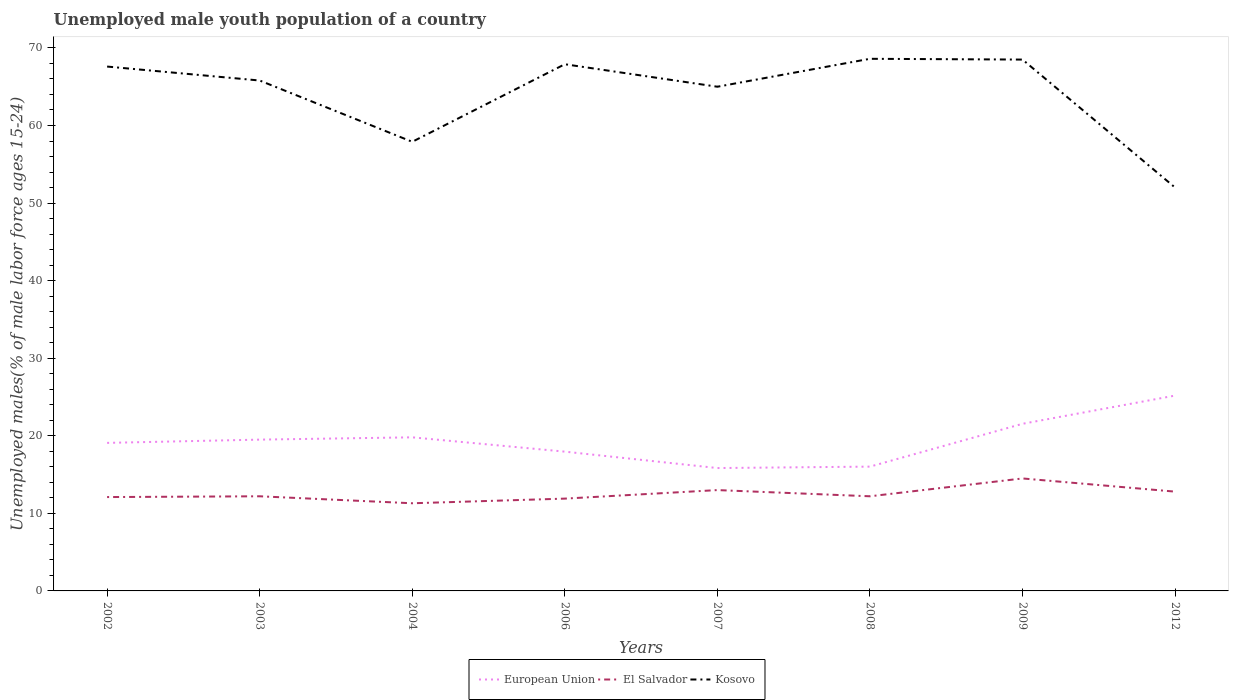How many different coloured lines are there?
Give a very brief answer. 3. Is the number of lines equal to the number of legend labels?
Provide a succinct answer. Yes. What is the total percentage of unemployed male youth population in Kosovo in the graph?
Your response must be concise. 0.1. What is the difference between the highest and the second highest percentage of unemployed male youth population in El Salvador?
Make the answer very short. 3.2. What is the difference between the highest and the lowest percentage of unemployed male youth population in El Salvador?
Your answer should be very brief. 3. How many lines are there?
Provide a succinct answer. 3. How many years are there in the graph?
Ensure brevity in your answer.  8. How are the legend labels stacked?
Your answer should be very brief. Horizontal. What is the title of the graph?
Offer a very short reply. Unemployed male youth population of a country. What is the label or title of the Y-axis?
Offer a terse response. Unemployed males(% of male labor force ages 15-24). What is the Unemployed males(% of male labor force ages 15-24) of European Union in 2002?
Ensure brevity in your answer.  19.08. What is the Unemployed males(% of male labor force ages 15-24) in El Salvador in 2002?
Make the answer very short. 12.1. What is the Unemployed males(% of male labor force ages 15-24) in Kosovo in 2002?
Provide a short and direct response. 67.6. What is the Unemployed males(% of male labor force ages 15-24) of European Union in 2003?
Offer a very short reply. 19.51. What is the Unemployed males(% of male labor force ages 15-24) of El Salvador in 2003?
Give a very brief answer. 12.2. What is the Unemployed males(% of male labor force ages 15-24) in Kosovo in 2003?
Offer a terse response. 65.8. What is the Unemployed males(% of male labor force ages 15-24) of European Union in 2004?
Make the answer very short. 19.8. What is the Unemployed males(% of male labor force ages 15-24) in El Salvador in 2004?
Offer a very short reply. 11.3. What is the Unemployed males(% of male labor force ages 15-24) of Kosovo in 2004?
Provide a succinct answer. 57.9. What is the Unemployed males(% of male labor force ages 15-24) of European Union in 2006?
Your answer should be compact. 17.96. What is the Unemployed males(% of male labor force ages 15-24) in El Salvador in 2006?
Offer a very short reply. 11.9. What is the Unemployed males(% of male labor force ages 15-24) of Kosovo in 2006?
Provide a short and direct response. 67.9. What is the Unemployed males(% of male labor force ages 15-24) in European Union in 2007?
Offer a terse response. 15.84. What is the Unemployed males(% of male labor force ages 15-24) in El Salvador in 2007?
Your answer should be compact. 13. What is the Unemployed males(% of male labor force ages 15-24) in Kosovo in 2007?
Offer a very short reply. 65. What is the Unemployed males(% of male labor force ages 15-24) in European Union in 2008?
Make the answer very short. 16.02. What is the Unemployed males(% of male labor force ages 15-24) of El Salvador in 2008?
Provide a succinct answer. 12.2. What is the Unemployed males(% of male labor force ages 15-24) of Kosovo in 2008?
Your answer should be compact. 68.6. What is the Unemployed males(% of male labor force ages 15-24) in European Union in 2009?
Provide a succinct answer. 21.55. What is the Unemployed males(% of male labor force ages 15-24) of El Salvador in 2009?
Provide a succinct answer. 14.5. What is the Unemployed males(% of male labor force ages 15-24) in Kosovo in 2009?
Give a very brief answer. 68.5. What is the Unemployed males(% of male labor force ages 15-24) of European Union in 2012?
Give a very brief answer. 25.18. What is the Unemployed males(% of male labor force ages 15-24) in El Salvador in 2012?
Provide a short and direct response. 12.8. What is the Unemployed males(% of male labor force ages 15-24) in Kosovo in 2012?
Your answer should be very brief. 52. Across all years, what is the maximum Unemployed males(% of male labor force ages 15-24) of European Union?
Provide a short and direct response. 25.18. Across all years, what is the maximum Unemployed males(% of male labor force ages 15-24) of Kosovo?
Ensure brevity in your answer.  68.6. Across all years, what is the minimum Unemployed males(% of male labor force ages 15-24) of European Union?
Your response must be concise. 15.84. Across all years, what is the minimum Unemployed males(% of male labor force ages 15-24) of El Salvador?
Give a very brief answer. 11.3. Across all years, what is the minimum Unemployed males(% of male labor force ages 15-24) in Kosovo?
Give a very brief answer. 52. What is the total Unemployed males(% of male labor force ages 15-24) of European Union in the graph?
Your response must be concise. 154.94. What is the total Unemployed males(% of male labor force ages 15-24) of Kosovo in the graph?
Your response must be concise. 513.3. What is the difference between the Unemployed males(% of male labor force ages 15-24) in European Union in 2002 and that in 2003?
Offer a terse response. -0.42. What is the difference between the Unemployed males(% of male labor force ages 15-24) of El Salvador in 2002 and that in 2003?
Ensure brevity in your answer.  -0.1. What is the difference between the Unemployed males(% of male labor force ages 15-24) in European Union in 2002 and that in 2004?
Your answer should be very brief. -0.72. What is the difference between the Unemployed males(% of male labor force ages 15-24) in El Salvador in 2002 and that in 2004?
Ensure brevity in your answer.  0.8. What is the difference between the Unemployed males(% of male labor force ages 15-24) of Kosovo in 2002 and that in 2004?
Provide a short and direct response. 9.7. What is the difference between the Unemployed males(% of male labor force ages 15-24) in European Union in 2002 and that in 2006?
Keep it short and to the point. 1.13. What is the difference between the Unemployed males(% of male labor force ages 15-24) of El Salvador in 2002 and that in 2006?
Provide a short and direct response. 0.2. What is the difference between the Unemployed males(% of male labor force ages 15-24) of Kosovo in 2002 and that in 2006?
Offer a very short reply. -0.3. What is the difference between the Unemployed males(% of male labor force ages 15-24) in European Union in 2002 and that in 2007?
Your answer should be compact. 3.24. What is the difference between the Unemployed males(% of male labor force ages 15-24) in Kosovo in 2002 and that in 2007?
Keep it short and to the point. 2.6. What is the difference between the Unemployed males(% of male labor force ages 15-24) of European Union in 2002 and that in 2008?
Your answer should be very brief. 3.06. What is the difference between the Unemployed males(% of male labor force ages 15-24) of El Salvador in 2002 and that in 2008?
Offer a terse response. -0.1. What is the difference between the Unemployed males(% of male labor force ages 15-24) in European Union in 2002 and that in 2009?
Your answer should be very brief. -2.46. What is the difference between the Unemployed males(% of male labor force ages 15-24) of Kosovo in 2002 and that in 2009?
Make the answer very short. -0.9. What is the difference between the Unemployed males(% of male labor force ages 15-24) of European Union in 2002 and that in 2012?
Keep it short and to the point. -6.1. What is the difference between the Unemployed males(% of male labor force ages 15-24) of El Salvador in 2002 and that in 2012?
Ensure brevity in your answer.  -0.7. What is the difference between the Unemployed males(% of male labor force ages 15-24) of European Union in 2003 and that in 2004?
Offer a terse response. -0.3. What is the difference between the Unemployed males(% of male labor force ages 15-24) of European Union in 2003 and that in 2006?
Your response must be concise. 1.55. What is the difference between the Unemployed males(% of male labor force ages 15-24) in El Salvador in 2003 and that in 2006?
Your answer should be compact. 0.3. What is the difference between the Unemployed males(% of male labor force ages 15-24) of Kosovo in 2003 and that in 2006?
Ensure brevity in your answer.  -2.1. What is the difference between the Unemployed males(% of male labor force ages 15-24) in European Union in 2003 and that in 2007?
Your answer should be compact. 3.66. What is the difference between the Unemployed males(% of male labor force ages 15-24) in El Salvador in 2003 and that in 2007?
Your answer should be compact. -0.8. What is the difference between the Unemployed males(% of male labor force ages 15-24) of European Union in 2003 and that in 2008?
Offer a terse response. 3.48. What is the difference between the Unemployed males(% of male labor force ages 15-24) of European Union in 2003 and that in 2009?
Provide a short and direct response. -2.04. What is the difference between the Unemployed males(% of male labor force ages 15-24) in El Salvador in 2003 and that in 2009?
Keep it short and to the point. -2.3. What is the difference between the Unemployed males(% of male labor force ages 15-24) of European Union in 2003 and that in 2012?
Provide a short and direct response. -5.68. What is the difference between the Unemployed males(% of male labor force ages 15-24) in El Salvador in 2003 and that in 2012?
Give a very brief answer. -0.6. What is the difference between the Unemployed males(% of male labor force ages 15-24) of European Union in 2004 and that in 2006?
Offer a very short reply. 1.85. What is the difference between the Unemployed males(% of male labor force ages 15-24) of Kosovo in 2004 and that in 2006?
Offer a terse response. -10. What is the difference between the Unemployed males(% of male labor force ages 15-24) in European Union in 2004 and that in 2007?
Provide a short and direct response. 3.96. What is the difference between the Unemployed males(% of male labor force ages 15-24) of European Union in 2004 and that in 2008?
Ensure brevity in your answer.  3.78. What is the difference between the Unemployed males(% of male labor force ages 15-24) in Kosovo in 2004 and that in 2008?
Your answer should be compact. -10.7. What is the difference between the Unemployed males(% of male labor force ages 15-24) of European Union in 2004 and that in 2009?
Make the answer very short. -1.74. What is the difference between the Unemployed males(% of male labor force ages 15-24) of Kosovo in 2004 and that in 2009?
Make the answer very short. -10.6. What is the difference between the Unemployed males(% of male labor force ages 15-24) in European Union in 2004 and that in 2012?
Keep it short and to the point. -5.38. What is the difference between the Unemployed males(% of male labor force ages 15-24) of Kosovo in 2004 and that in 2012?
Your answer should be compact. 5.9. What is the difference between the Unemployed males(% of male labor force ages 15-24) in European Union in 2006 and that in 2007?
Ensure brevity in your answer.  2.12. What is the difference between the Unemployed males(% of male labor force ages 15-24) of El Salvador in 2006 and that in 2007?
Make the answer very short. -1.1. What is the difference between the Unemployed males(% of male labor force ages 15-24) of Kosovo in 2006 and that in 2007?
Make the answer very short. 2.9. What is the difference between the Unemployed males(% of male labor force ages 15-24) in European Union in 2006 and that in 2008?
Keep it short and to the point. 1.93. What is the difference between the Unemployed males(% of male labor force ages 15-24) in European Union in 2006 and that in 2009?
Your answer should be compact. -3.59. What is the difference between the Unemployed males(% of male labor force ages 15-24) of European Union in 2006 and that in 2012?
Your response must be concise. -7.23. What is the difference between the Unemployed males(% of male labor force ages 15-24) in Kosovo in 2006 and that in 2012?
Offer a very short reply. 15.9. What is the difference between the Unemployed males(% of male labor force ages 15-24) in European Union in 2007 and that in 2008?
Your answer should be compact. -0.18. What is the difference between the Unemployed males(% of male labor force ages 15-24) of El Salvador in 2007 and that in 2008?
Your response must be concise. 0.8. What is the difference between the Unemployed males(% of male labor force ages 15-24) in European Union in 2007 and that in 2009?
Provide a short and direct response. -5.7. What is the difference between the Unemployed males(% of male labor force ages 15-24) in El Salvador in 2007 and that in 2009?
Offer a very short reply. -1.5. What is the difference between the Unemployed males(% of male labor force ages 15-24) of Kosovo in 2007 and that in 2009?
Provide a short and direct response. -3.5. What is the difference between the Unemployed males(% of male labor force ages 15-24) in European Union in 2007 and that in 2012?
Ensure brevity in your answer.  -9.34. What is the difference between the Unemployed males(% of male labor force ages 15-24) in El Salvador in 2007 and that in 2012?
Make the answer very short. 0.2. What is the difference between the Unemployed males(% of male labor force ages 15-24) of Kosovo in 2007 and that in 2012?
Your answer should be very brief. 13. What is the difference between the Unemployed males(% of male labor force ages 15-24) of European Union in 2008 and that in 2009?
Your answer should be very brief. -5.52. What is the difference between the Unemployed males(% of male labor force ages 15-24) of Kosovo in 2008 and that in 2009?
Your answer should be compact. 0.1. What is the difference between the Unemployed males(% of male labor force ages 15-24) of European Union in 2008 and that in 2012?
Offer a terse response. -9.16. What is the difference between the Unemployed males(% of male labor force ages 15-24) of European Union in 2009 and that in 2012?
Your response must be concise. -3.64. What is the difference between the Unemployed males(% of male labor force ages 15-24) in Kosovo in 2009 and that in 2012?
Provide a succinct answer. 16.5. What is the difference between the Unemployed males(% of male labor force ages 15-24) in European Union in 2002 and the Unemployed males(% of male labor force ages 15-24) in El Salvador in 2003?
Provide a short and direct response. 6.88. What is the difference between the Unemployed males(% of male labor force ages 15-24) in European Union in 2002 and the Unemployed males(% of male labor force ages 15-24) in Kosovo in 2003?
Your answer should be very brief. -46.72. What is the difference between the Unemployed males(% of male labor force ages 15-24) of El Salvador in 2002 and the Unemployed males(% of male labor force ages 15-24) of Kosovo in 2003?
Keep it short and to the point. -53.7. What is the difference between the Unemployed males(% of male labor force ages 15-24) in European Union in 2002 and the Unemployed males(% of male labor force ages 15-24) in El Salvador in 2004?
Your response must be concise. 7.78. What is the difference between the Unemployed males(% of male labor force ages 15-24) of European Union in 2002 and the Unemployed males(% of male labor force ages 15-24) of Kosovo in 2004?
Your answer should be very brief. -38.82. What is the difference between the Unemployed males(% of male labor force ages 15-24) in El Salvador in 2002 and the Unemployed males(% of male labor force ages 15-24) in Kosovo in 2004?
Your answer should be compact. -45.8. What is the difference between the Unemployed males(% of male labor force ages 15-24) of European Union in 2002 and the Unemployed males(% of male labor force ages 15-24) of El Salvador in 2006?
Offer a terse response. 7.18. What is the difference between the Unemployed males(% of male labor force ages 15-24) of European Union in 2002 and the Unemployed males(% of male labor force ages 15-24) of Kosovo in 2006?
Provide a short and direct response. -48.82. What is the difference between the Unemployed males(% of male labor force ages 15-24) of El Salvador in 2002 and the Unemployed males(% of male labor force ages 15-24) of Kosovo in 2006?
Your answer should be very brief. -55.8. What is the difference between the Unemployed males(% of male labor force ages 15-24) of European Union in 2002 and the Unemployed males(% of male labor force ages 15-24) of El Salvador in 2007?
Ensure brevity in your answer.  6.08. What is the difference between the Unemployed males(% of male labor force ages 15-24) of European Union in 2002 and the Unemployed males(% of male labor force ages 15-24) of Kosovo in 2007?
Offer a terse response. -45.92. What is the difference between the Unemployed males(% of male labor force ages 15-24) in El Salvador in 2002 and the Unemployed males(% of male labor force ages 15-24) in Kosovo in 2007?
Offer a very short reply. -52.9. What is the difference between the Unemployed males(% of male labor force ages 15-24) of European Union in 2002 and the Unemployed males(% of male labor force ages 15-24) of El Salvador in 2008?
Your answer should be compact. 6.88. What is the difference between the Unemployed males(% of male labor force ages 15-24) of European Union in 2002 and the Unemployed males(% of male labor force ages 15-24) of Kosovo in 2008?
Provide a short and direct response. -49.52. What is the difference between the Unemployed males(% of male labor force ages 15-24) in El Salvador in 2002 and the Unemployed males(% of male labor force ages 15-24) in Kosovo in 2008?
Offer a very short reply. -56.5. What is the difference between the Unemployed males(% of male labor force ages 15-24) of European Union in 2002 and the Unemployed males(% of male labor force ages 15-24) of El Salvador in 2009?
Make the answer very short. 4.58. What is the difference between the Unemployed males(% of male labor force ages 15-24) in European Union in 2002 and the Unemployed males(% of male labor force ages 15-24) in Kosovo in 2009?
Provide a succinct answer. -49.42. What is the difference between the Unemployed males(% of male labor force ages 15-24) in El Salvador in 2002 and the Unemployed males(% of male labor force ages 15-24) in Kosovo in 2009?
Give a very brief answer. -56.4. What is the difference between the Unemployed males(% of male labor force ages 15-24) of European Union in 2002 and the Unemployed males(% of male labor force ages 15-24) of El Salvador in 2012?
Offer a terse response. 6.28. What is the difference between the Unemployed males(% of male labor force ages 15-24) in European Union in 2002 and the Unemployed males(% of male labor force ages 15-24) in Kosovo in 2012?
Provide a succinct answer. -32.92. What is the difference between the Unemployed males(% of male labor force ages 15-24) in El Salvador in 2002 and the Unemployed males(% of male labor force ages 15-24) in Kosovo in 2012?
Your answer should be compact. -39.9. What is the difference between the Unemployed males(% of male labor force ages 15-24) of European Union in 2003 and the Unemployed males(% of male labor force ages 15-24) of El Salvador in 2004?
Give a very brief answer. 8.21. What is the difference between the Unemployed males(% of male labor force ages 15-24) in European Union in 2003 and the Unemployed males(% of male labor force ages 15-24) in Kosovo in 2004?
Your answer should be very brief. -38.39. What is the difference between the Unemployed males(% of male labor force ages 15-24) of El Salvador in 2003 and the Unemployed males(% of male labor force ages 15-24) of Kosovo in 2004?
Your response must be concise. -45.7. What is the difference between the Unemployed males(% of male labor force ages 15-24) in European Union in 2003 and the Unemployed males(% of male labor force ages 15-24) in El Salvador in 2006?
Give a very brief answer. 7.61. What is the difference between the Unemployed males(% of male labor force ages 15-24) of European Union in 2003 and the Unemployed males(% of male labor force ages 15-24) of Kosovo in 2006?
Your response must be concise. -48.39. What is the difference between the Unemployed males(% of male labor force ages 15-24) in El Salvador in 2003 and the Unemployed males(% of male labor force ages 15-24) in Kosovo in 2006?
Ensure brevity in your answer.  -55.7. What is the difference between the Unemployed males(% of male labor force ages 15-24) in European Union in 2003 and the Unemployed males(% of male labor force ages 15-24) in El Salvador in 2007?
Offer a very short reply. 6.51. What is the difference between the Unemployed males(% of male labor force ages 15-24) of European Union in 2003 and the Unemployed males(% of male labor force ages 15-24) of Kosovo in 2007?
Your response must be concise. -45.49. What is the difference between the Unemployed males(% of male labor force ages 15-24) in El Salvador in 2003 and the Unemployed males(% of male labor force ages 15-24) in Kosovo in 2007?
Your answer should be very brief. -52.8. What is the difference between the Unemployed males(% of male labor force ages 15-24) of European Union in 2003 and the Unemployed males(% of male labor force ages 15-24) of El Salvador in 2008?
Give a very brief answer. 7.31. What is the difference between the Unemployed males(% of male labor force ages 15-24) in European Union in 2003 and the Unemployed males(% of male labor force ages 15-24) in Kosovo in 2008?
Provide a short and direct response. -49.09. What is the difference between the Unemployed males(% of male labor force ages 15-24) in El Salvador in 2003 and the Unemployed males(% of male labor force ages 15-24) in Kosovo in 2008?
Offer a terse response. -56.4. What is the difference between the Unemployed males(% of male labor force ages 15-24) of European Union in 2003 and the Unemployed males(% of male labor force ages 15-24) of El Salvador in 2009?
Your response must be concise. 5.01. What is the difference between the Unemployed males(% of male labor force ages 15-24) of European Union in 2003 and the Unemployed males(% of male labor force ages 15-24) of Kosovo in 2009?
Your answer should be very brief. -48.99. What is the difference between the Unemployed males(% of male labor force ages 15-24) of El Salvador in 2003 and the Unemployed males(% of male labor force ages 15-24) of Kosovo in 2009?
Provide a succinct answer. -56.3. What is the difference between the Unemployed males(% of male labor force ages 15-24) in European Union in 2003 and the Unemployed males(% of male labor force ages 15-24) in El Salvador in 2012?
Keep it short and to the point. 6.71. What is the difference between the Unemployed males(% of male labor force ages 15-24) in European Union in 2003 and the Unemployed males(% of male labor force ages 15-24) in Kosovo in 2012?
Offer a terse response. -32.49. What is the difference between the Unemployed males(% of male labor force ages 15-24) in El Salvador in 2003 and the Unemployed males(% of male labor force ages 15-24) in Kosovo in 2012?
Offer a very short reply. -39.8. What is the difference between the Unemployed males(% of male labor force ages 15-24) of European Union in 2004 and the Unemployed males(% of male labor force ages 15-24) of El Salvador in 2006?
Your answer should be very brief. 7.9. What is the difference between the Unemployed males(% of male labor force ages 15-24) in European Union in 2004 and the Unemployed males(% of male labor force ages 15-24) in Kosovo in 2006?
Offer a terse response. -48.1. What is the difference between the Unemployed males(% of male labor force ages 15-24) of El Salvador in 2004 and the Unemployed males(% of male labor force ages 15-24) of Kosovo in 2006?
Provide a succinct answer. -56.6. What is the difference between the Unemployed males(% of male labor force ages 15-24) in European Union in 2004 and the Unemployed males(% of male labor force ages 15-24) in El Salvador in 2007?
Give a very brief answer. 6.8. What is the difference between the Unemployed males(% of male labor force ages 15-24) in European Union in 2004 and the Unemployed males(% of male labor force ages 15-24) in Kosovo in 2007?
Provide a short and direct response. -45.2. What is the difference between the Unemployed males(% of male labor force ages 15-24) of El Salvador in 2004 and the Unemployed males(% of male labor force ages 15-24) of Kosovo in 2007?
Offer a very short reply. -53.7. What is the difference between the Unemployed males(% of male labor force ages 15-24) of European Union in 2004 and the Unemployed males(% of male labor force ages 15-24) of El Salvador in 2008?
Your response must be concise. 7.6. What is the difference between the Unemployed males(% of male labor force ages 15-24) of European Union in 2004 and the Unemployed males(% of male labor force ages 15-24) of Kosovo in 2008?
Provide a succinct answer. -48.8. What is the difference between the Unemployed males(% of male labor force ages 15-24) of El Salvador in 2004 and the Unemployed males(% of male labor force ages 15-24) of Kosovo in 2008?
Your answer should be very brief. -57.3. What is the difference between the Unemployed males(% of male labor force ages 15-24) of European Union in 2004 and the Unemployed males(% of male labor force ages 15-24) of El Salvador in 2009?
Ensure brevity in your answer.  5.3. What is the difference between the Unemployed males(% of male labor force ages 15-24) of European Union in 2004 and the Unemployed males(% of male labor force ages 15-24) of Kosovo in 2009?
Offer a very short reply. -48.7. What is the difference between the Unemployed males(% of male labor force ages 15-24) of El Salvador in 2004 and the Unemployed males(% of male labor force ages 15-24) of Kosovo in 2009?
Ensure brevity in your answer.  -57.2. What is the difference between the Unemployed males(% of male labor force ages 15-24) in European Union in 2004 and the Unemployed males(% of male labor force ages 15-24) in El Salvador in 2012?
Make the answer very short. 7. What is the difference between the Unemployed males(% of male labor force ages 15-24) of European Union in 2004 and the Unemployed males(% of male labor force ages 15-24) of Kosovo in 2012?
Offer a terse response. -32.2. What is the difference between the Unemployed males(% of male labor force ages 15-24) in El Salvador in 2004 and the Unemployed males(% of male labor force ages 15-24) in Kosovo in 2012?
Provide a short and direct response. -40.7. What is the difference between the Unemployed males(% of male labor force ages 15-24) in European Union in 2006 and the Unemployed males(% of male labor force ages 15-24) in El Salvador in 2007?
Make the answer very short. 4.96. What is the difference between the Unemployed males(% of male labor force ages 15-24) in European Union in 2006 and the Unemployed males(% of male labor force ages 15-24) in Kosovo in 2007?
Your response must be concise. -47.04. What is the difference between the Unemployed males(% of male labor force ages 15-24) of El Salvador in 2006 and the Unemployed males(% of male labor force ages 15-24) of Kosovo in 2007?
Make the answer very short. -53.1. What is the difference between the Unemployed males(% of male labor force ages 15-24) of European Union in 2006 and the Unemployed males(% of male labor force ages 15-24) of El Salvador in 2008?
Provide a succinct answer. 5.76. What is the difference between the Unemployed males(% of male labor force ages 15-24) in European Union in 2006 and the Unemployed males(% of male labor force ages 15-24) in Kosovo in 2008?
Keep it short and to the point. -50.64. What is the difference between the Unemployed males(% of male labor force ages 15-24) in El Salvador in 2006 and the Unemployed males(% of male labor force ages 15-24) in Kosovo in 2008?
Make the answer very short. -56.7. What is the difference between the Unemployed males(% of male labor force ages 15-24) of European Union in 2006 and the Unemployed males(% of male labor force ages 15-24) of El Salvador in 2009?
Offer a very short reply. 3.46. What is the difference between the Unemployed males(% of male labor force ages 15-24) in European Union in 2006 and the Unemployed males(% of male labor force ages 15-24) in Kosovo in 2009?
Your response must be concise. -50.54. What is the difference between the Unemployed males(% of male labor force ages 15-24) in El Salvador in 2006 and the Unemployed males(% of male labor force ages 15-24) in Kosovo in 2009?
Make the answer very short. -56.6. What is the difference between the Unemployed males(% of male labor force ages 15-24) in European Union in 2006 and the Unemployed males(% of male labor force ages 15-24) in El Salvador in 2012?
Ensure brevity in your answer.  5.16. What is the difference between the Unemployed males(% of male labor force ages 15-24) in European Union in 2006 and the Unemployed males(% of male labor force ages 15-24) in Kosovo in 2012?
Provide a short and direct response. -34.04. What is the difference between the Unemployed males(% of male labor force ages 15-24) in El Salvador in 2006 and the Unemployed males(% of male labor force ages 15-24) in Kosovo in 2012?
Ensure brevity in your answer.  -40.1. What is the difference between the Unemployed males(% of male labor force ages 15-24) of European Union in 2007 and the Unemployed males(% of male labor force ages 15-24) of El Salvador in 2008?
Keep it short and to the point. 3.64. What is the difference between the Unemployed males(% of male labor force ages 15-24) of European Union in 2007 and the Unemployed males(% of male labor force ages 15-24) of Kosovo in 2008?
Keep it short and to the point. -52.76. What is the difference between the Unemployed males(% of male labor force ages 15-24) in El Salvador in 2007 and the Unemployed males(% of male labor force ages 15-24) in Kosovo in 2008?
Offer a very short reply. -55.6. What is the difference between the Unemployed males(% of male labor force ages 15-24) in European Union in 2007 and the Unemployed males(% of male labor force ages 15-24) in El Salvador in 2009?
Your response must be concise. 1.34. What is the difference between the Unemployed males(% of male labor force ages 15-24) in European Union in 2007 and the Unemployed males(% of male labor force ages 15-24) in Kosovo in 2009?
Give a very brief answer. -52.66. What is the difference between the Unemployed males(% of male labor force ages 15-24) in El Salvador in 2007 and the Unemployed males(% of male labor force ages 15-24) in Kosovo in 2009?
Your response must be concise. -55.5. What is the difference between the Unemployed males(% of male labor force ages 15-24) of European Union in 2007 and the Unemployed males(% of male labor force ages 15-24) of El Salvador in 2012?
Your response must be concise. 3.04. What is the difference between the Unemployed males(% of male labor force ages 15-24) of European Union in 2007 and the Unemployed males(% of male labor force ages 15-24) of Kosovo in 2012?
Ensure brevity in your answer.  -36.16. What is the difference between the Unemployed males(% of male labor force ages 15-24) in El Salvador in 2007 and the Unemployed males(% of male labor force ages 15-24) in Kosovo in 2012?
Your response must be concise. -39. What is the difference between the Unemployed males(% of male labor force ages 15-24) in European Union in 2008 and the Unemployed males(% of male labor force ages 15-24) in El Salvador in 2009?
Offer a terse response. 1.52. What is the difference between the Unemployed males(% of male labor force ages 15-24) in European Union in 2008 and the Unemployed males(% of male labor force ages 15-24) in Kosovo in 2009?
Your answer should be compact. -52.48. What is the difference between the Unemployed males(% of male labor force ages 15-24) in El Salvador in 2008 and the Unemployed males(% of male labor force ages 15-24) in Kosovo in 2009?
Make the answer very short. -56.3. What is the difference between the Unemployed males(% of male labor force ages 15-24) in European Union in 2008 and the Unemployed males(% of male labor force ages 15-24) in El Salvador in 2012?
Your answer should be compact. 3.22. What is the difference between the Unemployed males(% of male labor force ages 15-24) of European Union in 2008 and the Unemployed males(% of male labor force ages 15-24) of Kosovo in 2012?
Your answer should be very brief. -35.98. What is the difference between the Unemployed males(% of male labor force ages 15-24) in El Salvador in 2008 and the Unemployed males(% of male labor force ages 15-24) in Kosovo in 2012?
Your answer should be compact. -39.8. What is the difference between the Unemployed males(% of male labor force ages 15-24) of European Union in 2009 and the Unemployed males(% of male labor force ages 15-24) of El Salvador in 2012?
Your response must be concise. 8.75. What is the difference between the Unemployed males(% of male labor force ages 15-24) of European Union in 2009 and the Unemployed males(% of male labor force ages 15-24) of Kosovo in 2012?
Provide a succinct answer. -30.45. What is the difference between the Unemployed males(% of male labor force ages 15-24) in El Salvador in 2009 and the Unemployed males(% of male labor force ages 15-24) in Kosovo in 2012?
Your response must be concise. -37.5. What is the average Unemployed males(% of male labor force ages 15-24) in European Union per year?
Provide a succinct answer. 19.37. What is the average Unemployed males(% of male labor force ages 15-24) in El Salvador per year?
Ensure brevity in your answer.  12.5. What is the average Unemployed males(% of male labor force ages 15-24) in Kosovo per year?
Offer a very short reply. 64.16. In the year 2002, what is the difference between the Unemployed males(% of male labor force ages 15-24) of European Union and Unemployed males(% of male labor force ages 15-24) of El Salvador?
Your answer should be compact. 6.98. In the year 2002, what is the difference between the Unemployed males(% of male labor force ages 15-24) of European Union and Unemployed males(% of male labor force ages 15-24) of Kosovo?
Keep it short and to the point. -48.52. In the year 2002, what is the difference between the Unemployed males(% of male labor force ages 15-24) in El Salvador and Unemployed males(% of male labor force ages 15-24) in Kosovo?
Offer a terse response. -55.5. In the year 2003, what is the difference between the Unemployed males(% of male labor force ages 15-24) in European Union and Unemployed males(% of male labor force ages 15-24) in El Salvador?
Your response must be concise. 7.31. In the year 2003, what is the difference between the Unemployed males(% of male labor force ages 15-24) in European Union and Unemployed males(% of male labor force ages 15-24) in Kosovo?
Your answer should be compact. -46.29. In the year 2003, what is the difference between the Unemployed males(% of male labor force ages 15-24) of El Salvador and Unemployed males(% of male labor force ages 15-24) of Kosovo?
Provide a short and direct response. -53.6. In the year 2004, what is the difference between the Unemployed males(% of male labor force ages 15-24) in European Union and Unemployed males(% of male labor force ages 15-24) in El Salvador?
Offer a very short reply. 8.5. In the year 2004, what is the difference between the Unemployed males(% of male labor force ages 15-24) of European Union and Unemployed males(% of male labor force ages 15-24) of Kosovo?
Offer a terse response. -38.1. In the year 2004, what is the difference between the Unemployed males(% of male labor force ages 15-24) in El Salvador and Unemployed males(% of male labor force ages 15-24) in Kosovo?
Keep it short and to the point. -46.6. In the year 2006, what is the difference between the Unemployed males(% of male labor force ages 15-24) in European Union and Unemployed males(% of male labor force ages 15-24) in El Salvador?
Ensure brevity in your answer.  6.06. In the year 2006, what is the difference between the Unemployed males(% of male labor force ages 15-24) of European Union and Unemployed males(% of male labor force ages 15-24) of Kosovo?
Give a very brief answer. -49.94. In the year 2006, what is the difference between the Unemployed males(% of male labor force ages 15-24) of El Salvador and Unemployed males(% of male labor force ages 15-24) of Kosovo?
Your answer should be compact. -56. In the year 2007, what is the difference between the Unemployed males(% of male labor force ages 15-24) of European Union and Unemployed males(% of male labor force ages 15-24) of El Salvador?
Ensure brevity in your answer.  2.84. In the year 2007, what is the difference between the Unemployed males(% of male labor force ages 15-24) of European Union and Unemployed males(% of male labor force ages 15-24) of Kosovo?
Ensure brevity in your answer.  -49.16. In the year 2007, what is the difference between the Unemployed males(% of male labor force ages 15-24) of El Salvador and Unemployed males(% of male labor force ages 15-24) of Kosovo?
Your response must be concise. -52. In the year 2008, what is the difference between the Unemployed males(% of male labor force ages 15-24) in European Union and Unemployed males(% of male labor force ages 15-24) in El Salvador?
Give a very brief answer. 3.82. In the year 2008, what is the difference between the Unemployed males(% of male labor force ages 15-24) of European Union and Unemployed males(% of male labor force ages 15-24) of Kosovo?
Your answer should be compact. -52.58. In the year 2008, what is the difference between the Unemployed males(% of male labor force ages 15-24) in El Salvador and Unemployed males(% of male labor force ages 15-24) in Kosovo?
Offer a terse response. -56.4. In the year 2009, what is the difference between the Unemployed males(% of male labor force ages 15-24) of European Union and Unemployed males(% of male labor force ages 15-24) of El Salvador?
Give a very brief answer. 7.05. In the year 2009, what is the difference between the Unemployed males(% of male labor force ages 15-24) in European Union and Unemployed males(% of male labor force ages 15-24) in Kosovo?
Keep it short and to the point. -46.95. In the year 2009, what is the difference between the Unemployed males(% of male labor force ages 15-24) in El Salvador and Unemployed males(% of male labor force ages 15-24) in Kosovo?
Offer a terse response. -54. In the year 2012, what is the difference between the Unemployed males(% of male labor force ages 15-24) of European Union and Unemployed males(% of male labor force ages 15-24) of El Salvador?
Offer a terse response. 12.38. In the year 2012, what is the difference between the Unemployed males(% of male labor force ages 15-24) of European Union and Unemployed males(% of male labor force ages 15-24) of Kosovo?
Give a very brief answer. -26.82. In the year 2012, what is the difference between the Unemployed males(% of male labor force ages 15-24) in El Salvador and Unemployed males(% of male labor force ages 15-24) in Kosovo?
Provide a succinct answer. -39.2. What is the ratio of the Unemployed males(% of male labor force ages 15-24) in European Union in 2002 to that in 2003?
Provide a succinct answer. 0.98. What is the ratio of the Unemployed males(% of male labor force ages 15-24) of Kosovo in 2002 to that in 2003?
Keep it short and to the point. 1.03. What is the ratio of the Unemployed males(% of male labor force ages 15-24) in European Union in 2002 to that in 2004?
Give a very brief answer. 0.96. What is the ratio of the Unemployed males(% of male labor force ages 15-24) of El Salvador in 2002 to that in 2004?
Offer a very short reply. 1.07. What is the ratio of the Unemployed males(% of male labor force ages 15-24) in Kosovo in 2002 to that in 2004?
Give a very brief answer. 1.17. What is the ratio of the Unemployed males(% of male labor force ages 15-24) in European Union in 2002 to that in 2006?
Your answer should be very brief. 1.06. What is the ratio of the Unemployed males(% of male labor force ages 15-24) of El Salvador in 2002 to that in 2006?
Your answer should be very brief. 1.02. What is the ratio of the Unemployed males(% of male labor force ages 15-24) in Kosovo in 2002 to that in 2006?
Offer a very short reply. 1. What is the ratio of the Unemployed males(% of male labor force ages 15-24) of European Union in 2002 to that in 2007?
Ensure brevity in your answer.  1.2. What is the ratio of the Unemployed males(% of male labor force ages 15-24) in El Salvador in 2002 to that in 2007?
Your answer should be compact. 0.93. What is the ratio of the Unemployed males(% of male labor force ages 15-24) in European Union in 2002 to that in 2008?
Offer a terse response. 1.19. What is the ratio of the Unemployed males(% of male labor force ages 15-24) of El Salvador in 2002 to that in 2008?
Your response must be concise. 0.99. What is the ratio of the Unemployed males(% of male labor force ages 15-24) in Kosovo in 2002 to that in 2008?
Ensure brevity in your answer.  0.99. What is the ratio of the Unemployed males(% of male labor force ages 15-24) in European Union in 2002 to that in 2009?
Provide a short and direct response. 0.89. What is the ratio of the Unemployed males(% of male labor force ages 15-24) of El Salvador in 2002 to that in 2009?
Give a very brief answer. 0.83. What is the ratio of the Unemployed males(% of male labor force ages 15-24) of Kosovo in 2002 to that in 2009?
Make the answer very short. 0.99. What is the ratio of the Unemployed males(% of male labor force ages 15-24) in European Union in 2002 to that in 2012?
Offer a terse response. 0.76. What is the ratio of the Unemployed males(% of male labor force ages 15-24) in El Salvador in 2002 to that in 2012?
Ensure brevity in your answer.  0.95. What is the ratio of the Unemployed males(% of male labor force ages 15-24) in European Union in 2003 to that in 2004?
Give a very brief answer. 0.99. What is the ratio of the Unemployed males(% of male labor force ages 15-24) of El Salvador in 2003 to that in 2004?
Your response must be concise. 1.08. What is the ratio of the Unemployed males(% of male labor force ages 15-24) in Kosovo in 2003 to that in 2004?
Provide a short and direct response. 1.14. What is the ratio of the Unemployed males(% of male labor force ages 15-24) in European Union in 2003 to that in 2006?
Your answer should be compact. 1.09. What is the ratio of the Unemployed males(% of male labor force ages 15-24) in El Salvador in 2003 to that in 2006?
Offer a very short reply. 1.03. What is the ratio of the Unemployed males(% of male labor force ages 15-24) in Kosovo in 2003 to that in 2006?
Your response must be concise. 0.97. What is the ratio of the Unemployed males(% of male labor force ages 15-24) of European Union in 2003 to that in 2007?
Offer a very short reply. 1.23. What is the ratio of the Unemployed males(% of male labor force ages 15-24) in El Salvador in 2003 to that in 2007?
Your answer should be very brief. 0.94. What is the ratio of the Unemployed males(% of male labor force ages 15-24) of Kosovo in 2003 to that in 2007?
Provide a short and direct response. 1.01. What is the ratio of the Unemployed males(% of male labor force ages 15-24) of European Union in 2003 to that in 2008?
Ensure brevity in your answer.  1.22. What is the ratio of the Unemployed males(% of male labor force ages 15-24) in Kosovo in 2003 to that in 2008?
Your answer should be very brief. 0.96. What is the ratio of the Unemployed males(% of male labor force ages 15-24) of European Union in 2003 to that in 2009?
Ensure brevity in your answer.  0.91. What is the ratio of the Unemployed males(% of male labor force ages 15-24) in El Salvador in 2003 to that in 2009?
Ensure brevity in your answer.  0.84. What is the ratio of the Unemployed males(% of male labor force ages 15-24) in Kosovo in 2003 to that in 2009?
Offer a terse response. 0.96. What is the ratio of the Unemployed males(% of male labor force ages 15-24) in European Union in 2003 to that in 2012?
Your response must be concise. 0.77. What is the ratio of the Unemployed males(% of male labor force ages 15-24) in El Salvador in 2003 to that in 2012?
Provide a succinct answer. 0.95. What is the ratio of the Unemployed males(% of male labor force ages 15-24) in Kosovo in 2003 to that in 2012?
Offer a very short reply. 1.27. What is the ratio of the Unemployed males(% of male labor force ages 15-24) in European Union in 2004 to that in 2006?
Ensure brevity in your answer.  1.1. What is the ratio of the Unemployed males(% of male labor force ages 15-24) of El Salvador in 2004 to that in 2006?
Provide a short and direct response. 0.95. What is the ratio of the Unemployed males(% of male labor force ages 15-24) of Kosovo in 2004 to that in 2006?
Provide a short and direct response. 0.85. What is the ratio of the Unemployed males(% of male labor force ages 15-24) in European Union in 2004 to that in 2007?
Provide a short and direct response. 1.25. What is the ratio of the Unemployed males(% of male labor force ages 15-24) of El Salvador in 2004 to that in 2007?
Provide a succinct answer. 0.87. What is the ratio of the Unemployed males(% of male labor force ages 15-24) in Kosovo in 2004 to that in 2007?
Provide a succinct answer. 0.89. What is the ratio of the Unemployed males(% of male labor force ages 15-24) in European Union in 2004 to that in 2008?
Give a very brief answer. 1.24. What is the ratio of the Unemployed males(% of male labor force ages 15-24) in El Salvador in 2004 to that in 2008?
Keep it short and to the point. 0.93. What is the ratio of the Unemployed males(% of male labor force ages 15-24) in Kosovo in 2004 to that in 2008?
Make the answer very short. 0.84. What is the ratio of the Unemployed males(% of male labor force ages 15-24) in European Union in 2004 to that in 2009?
Your response must be concise. 0.92. What is the ratio of the Unemployed males(% of male labor force ages 15-24) of El Salvador in 2004 to that in 2009?
Provide a short and direct response. 0.78. What is the ratio of the Unemployed males(% of male labor force ages 15-24) in Kosovo in 2004 to that in 2009?
Provide a short and direct response. 0.85. What is the ratio of the Unemployed males(% of male labor force ages 15-24) of European Union in 2004 to that in 2012?
Provide a succinct answer. 0.79. What is the ratio of the Unemployed males(% of male labor force ages 15-24) of El Salvador in 2004 to that in 2012?
Offer a terse response. 0.88. What is the ratio of the Unemployed males(% of male labor force ages 15-24) of Kosovo in 2004 to that in 2012?
Offer a terse response. 1.11. What is the ratio of the Unemployed males(% of male labor force ages 15-24) of European Union in 2006 to that in 2007?
Offer a very short reply. 1.13. What is the ratio of the Unemployed males(% of male labor force ages 15-24) of El Salvador in 2006 to that in 2007?
Your answer should be compact. 0.92. What is the ratio of the Unemployed males(% of male labor force ages 15-24) in Kosovo in 2006 to that in 2007?
Offer a very short reply. 1.04. What is the ratio of the Unemployed males(% of male labor force ages 15-24) of European Union in 2006 to that in 2008?
Ensure brevity in your answer.  1.12. What is the ratio of the Unemployed males(% of male labor force ages 15-24) of El Salvador in 2006 to that in 2008?
Provide a succinct answer. 0.98. What is the ratio of the Unemployed males(% of male labor force ages 15-24) of Kosovo in 2006 to that in 2008?
Your answer should be very brief. 0.99. What is the ratio of the Unemployed males(% of male labor force ages 15-24) in European Union in 2006 to that in 2009?
Provide a succinct answer. 0.83. What is the ratio of the Unemployed males(% of male labor force ages 15-24) in El Salvador in 2006 to that in 2009?
Provide a short and direct response. 0.82. What is the ratio of the Unemployed males(% of male labor force ages 15-24) in European Union in 2006 to that in 2012?
Your answer should be compact. 0.71. What is the ratio of the Unemployed males(% of male labor force ages 15-24) of El Salvador in 2006 to that in 2012?
Offer a very short reply. 0.93. What is the ratio of the Unemployed males(% of male labor force ages 15-24) in Kosovo in 2006 to that in 2012?
Make the answer very short. 1.31. What is the ratio of the Unemployed males(% of male labor force ages 15-24) of El Salvador in 2007 to that in 2008?
Offer a terse response. 1.07. What is the ratio of the Unemployed males(% of male labor force ages 15-24) in Kosovo in 2007 to that in 2008?
Offer a very short reply. 0.95. What is the ratio of the Unemployed males(% of male labor force ages 15-24) of European Union in 2007 to that in 2009?
Your answer should be very brief. 0.74. What is the ratio of the Unemployed males(% of male labor force ages 15-24) of El Salvador in 2007 to that in 2009?
Your answer should be compact. 0.9. What is the ratio of the Unemployed males(% of male labor force ages 15-24) in Kosovo in 2007 to that in 2009?
Make the answer very short. 0.95. What is the ratio of the Unemployed males(% of male labor force ages 15-24) of European Union in 2007 to that in 2012?
Ensure brevity in your answer.  0.63. What is the ratio of the Unemployed males(% of male labor force ages 15-24) of El Salvador in 2007 to that in 2012?
Provide a short and direct response. 1.02. What is the ratio of the Unemployed males(% of male labor force ages 15-24) in European Union in 2008 to that in 2009?
Keep it short and to the point. 0.74. What is the ratio of the Unemployed males(% of male labor force ages 15-24) of El Salvador in 2008 to that in 2009?
Provide a succinct answer. 0.84. What is the ratio of the Unemployed males(% of male labor force ages 15-24) in Kosovo in 2008 to that in 2009?
Your response must be concise. 1. What is the ratio of the Unemployed males(% of male labor force ages 15-24) in European Union in 2008 to that in 2012?
Keep it short and to the point. 0.64. What is the ratio of the Unemployed males(% of male labor force ages 15-24) in El Salvador in 2008 to that in 2012?
Offer a very short reply. 0.95. What is the ratio of the Unemployed males(% of male labor force ages 15-24) in Kosovo in 2008 to that in 2012?
Your response must be concise. 1.32. What is the ratio of the Unemployed males(% of male labor force ages 15-24) in European Union in 2009 to that in 2012?
Ensure brevity in your answer.  0.86. What is the ratio of the Unemployed males(% of male labor force ages 15-24) of El Salvador in 2009 to that in 2012?
Your response must be concise. 1.13. What is the ratio of the Unemployed males(% of male labor force ages 15-24) of Kosovo in 2009 to that in 2012?
Your response must be concise. 1.32. What is the difference between the highest and the second highest Unemployed males(% of male labor force ages 15-24) of European Union?
Ensure brevity in your answer.  3.64. What is the difference between the highest and the lowest Unemployed males(% of male labor force ages 15-24) in European Union?
Your answer should be compact. 9.34. What is the difference between the highest and the lowest Unemployed males(% of male labor force ages 15-24) in El Salvador?
Provide a succinct answer. 3.2. What is the difference between the highest and the lowest Unemployed males(% of male labor force ages 15-24) of Kosovo?
Offer a terse response. 16.6. 